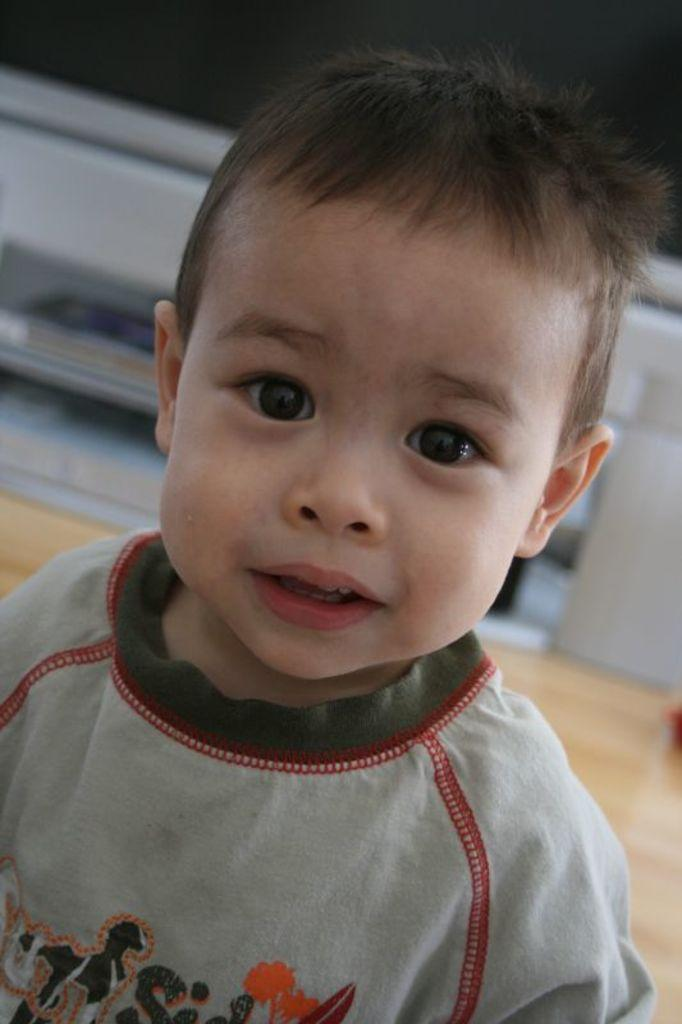Who is the main subject in the image? There is a boy in the image. Where is the boy positioned in the image? The boy is in the front. What is the boy wearing in the image? The boy is wearing a grey t-shirt. How many crates are stacked behind the boy in the image? There are no crates present in the image. What type of hill can be seen in the background of the image? There is no hill visible in the background of the image. 